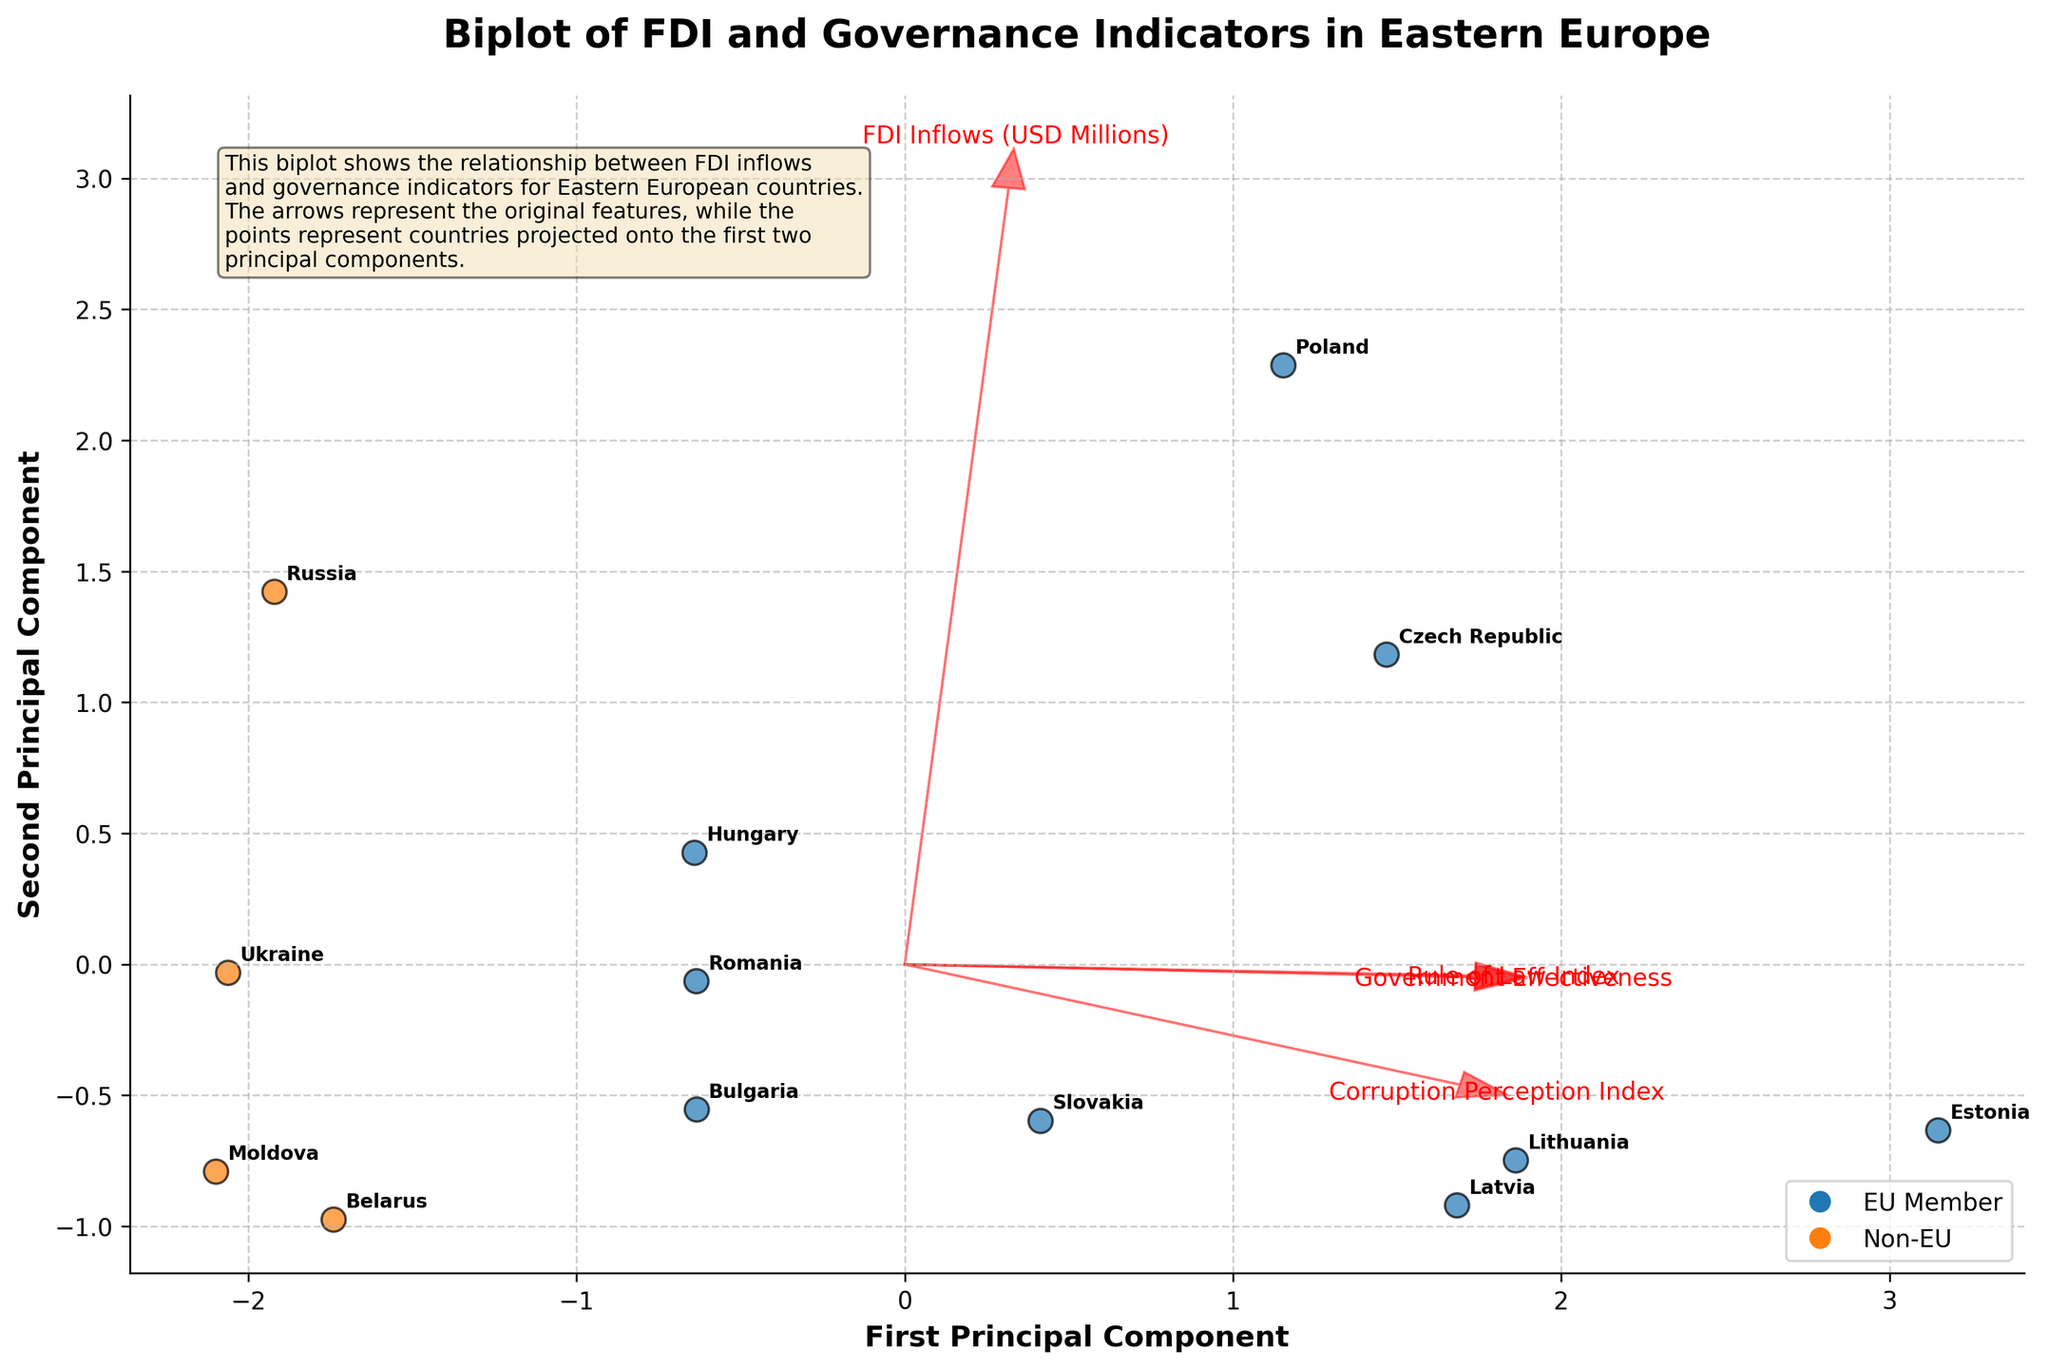What is the title of the biplot? The title is located at the top of the figure and describes the subject of the visualized data. The exact words should be taken as they appear in the figure.
Answer: Biplot of FDI and Governance Indicators in Eastern Europe How many data points represent EU countries in the biplot? The data points representing EU countries are depicted in a certain color (likely blue). Count the number of such colored points.
Answer: 8 Which country has the highest Government Effectiveness index? Find the arrows representing the governance indicators and identify the direction labeled as "Government Effectiveness". Determine the country closest to the tip of this arrow.
Answer: Estonia Is Ukraine an EU member according to the biplot? Look at the data point for Ukraine and identify its color. Match the color to the legend indicating EU or Non-EU membership status.
Answer: No What do the arrows in the biplot represent? The arrows point in the direction of increasing values for the respective features. These arrows are labeled with names of governance indicators and FDI inflows.
Answer: Features such as FDI Inflows, Corruption Perception Index, Rule of Law Index, and Government Effectiveness Which country has negative FDI Inflows? Identify the data points and look for the one that represents negative values on the feature vectors. There is only one country with negative FDI Inflows.
Answer: Belarus Between Poland and Hungary, which country shows a higher Rule of Law Index? Locate Poland and Hungary on the biplot. Check each country's position relative to the direction labeled as "Rule of Law Index" and see which one is further along the arrow's direction.
Answer: Poland What principal component explains the higher variance in the data? Check the length and direction of the axes labeled as "First Principal Component" and "Second Principal Component." The axis which encompasses a greater span of points explains higher variance.
Answer: First Principal Component Which governance indicator shows the least variability among the countries? The length and spread of the arrows indicate the variability of each feature. Identify the arrow with the shortest length and smallest spread among different countries.
Answer: Corruption Perception Index How is Lithuania positioned relative to Estonia in terms of the FDI Inflows and Government Effectiveness? Find Lithuania and Estonia on the plot, observe their positions relative to the arrows for FDI Inflows and Government Effectiveness. Compare their distances from the origin along these arrows.
Answer: Lithuania is lower than Estonia in both FDI Inflows and Government Effectiveness 